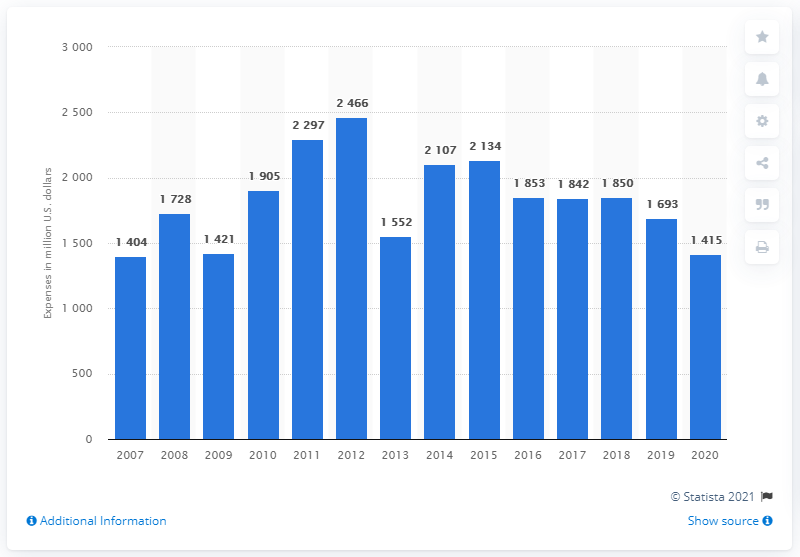Point out several critical features in this image. Caterpillar's expenses for research and development in the fiscal year of 2020 were approximately 1404. Caterpillar's expenses for research and development ended in 2020. In the fiscal year of 2007, Caterpillar's research and development was conducted. 